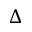<formula> <loc_0><loc_0><loc_500><loc_500>\Delta</formula> 